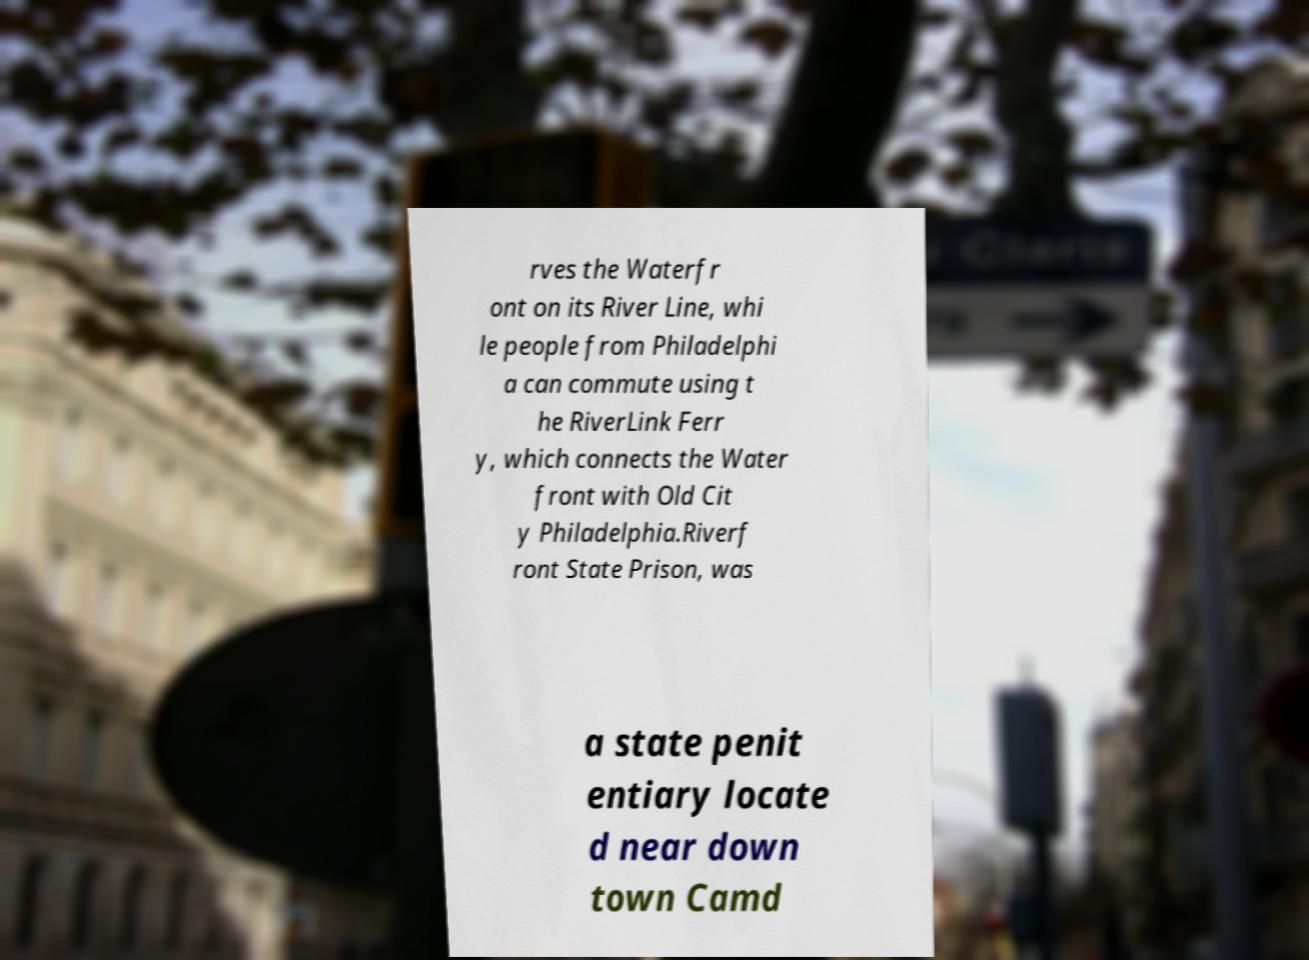For documentation purposes, I need the text within this image transcribed. Could you provide that? rves the Waterfr ont on its River Line, whi le people from Philadelphi a can commute using t he RiverLink Ferr y, which connects the Water front with Old Cit y Philadelphia.Riverf ront State Prison, was a state penit entiary locate d near down town Camd 